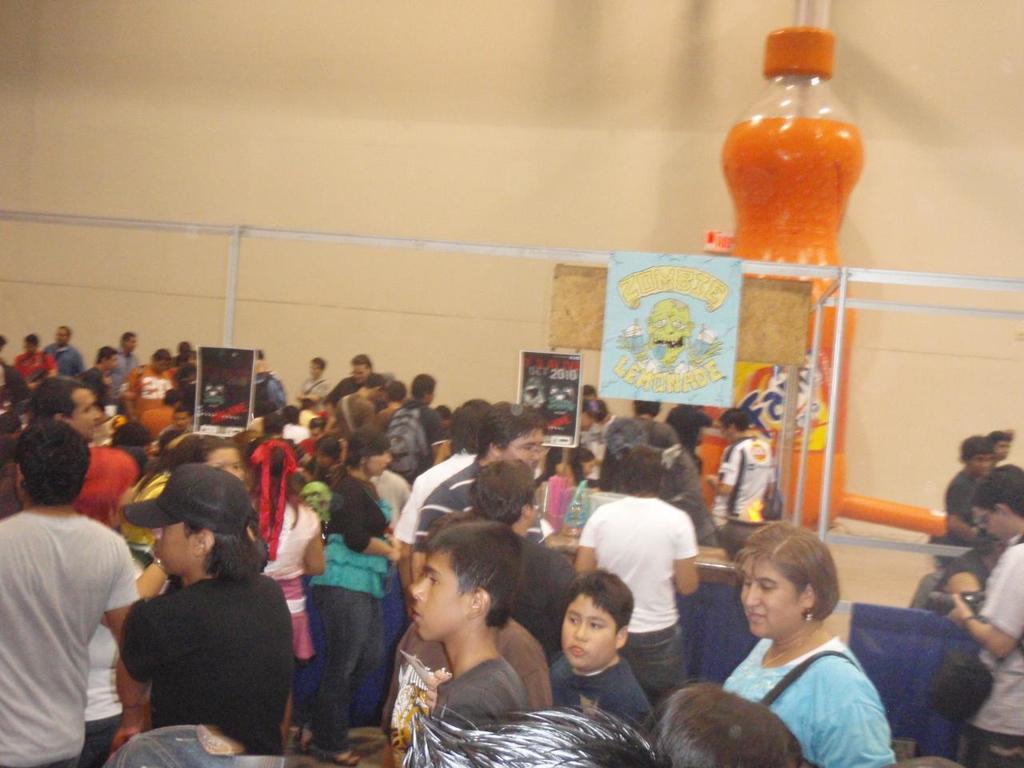Can you describe this image briefly? This picture is clicked inside. In the foreground we can see the group of persons seems to be standing. In the background there is a wall and we can see the metal rods and a posters on which we can see the text and some pictures and there is a sculpture of a bottle of drink. 